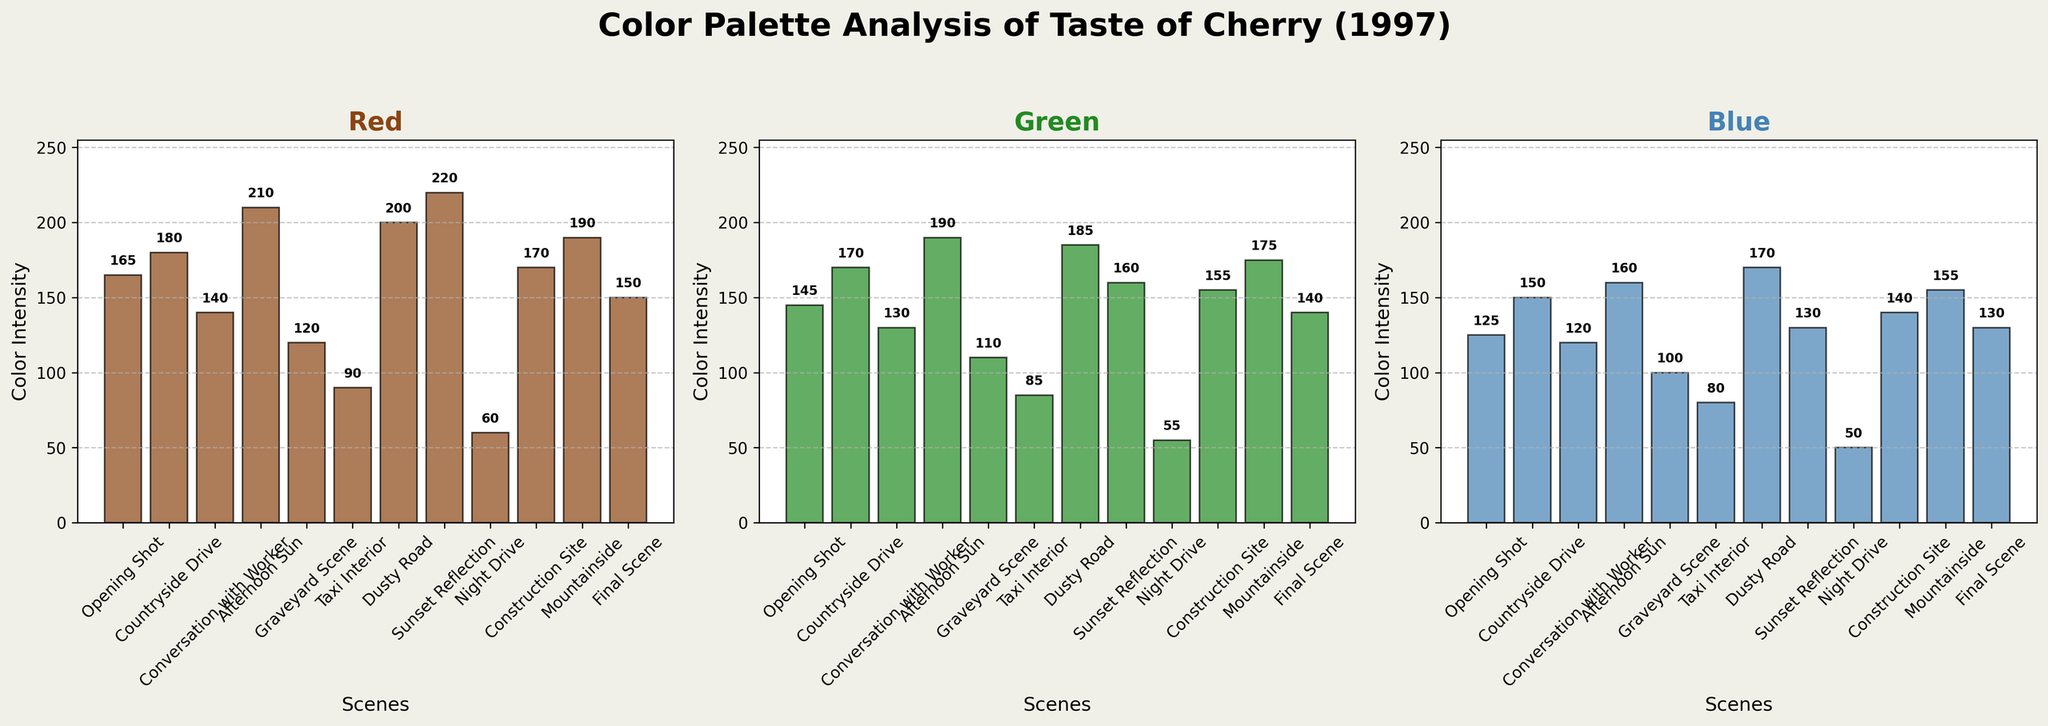What's the scene with the highest red intensity? Look at the plot representing the red intensity and identify which bar is the tallest.
Answer: Sunset Reflection Which scene has the lowest blue intensity? Observe the plot for blue intensity and find the shortest bar.
Answer: Night Drive What is the difference in green intensity between 'Afternoon Sun' and 'Night Drive'? Find the green intensity values for 'Afternoon Sun' (190) and 'Night Drive' (55), then subtract the latter from the former. 190 - 55 = 135
Answer: 135 What is the average blue intensity across all scenes? Sum all blue intensity values and divide by the number of scenes (12). (125+150+120+160+100+80+170+130+50+140+155+130)/12 ≈ 122.08
Answer: 122.08 Is the red intensity of 'Countryside Drive' higher than the red intensity of 'Final Scene'? Compare the red intensity values for 'Countryside Drive' (180) and 'Final Scene' (150). 180 > 150
Answer: Yes What is the total red intensity for 'Opening Shot', 'Graveyard Scene', and 'Taxi Interior'? Sum the red intensity values of 'Opening Shot' (165), 'Graveyard Scene' (120), and 'Taxi Interior' (90). 165 + 120 + 90 = 375
Answer: 375 Which color has the highest intensity in 'Mountainside'? Compare the intensity values of red (190), green (175), and blue (155) for 'Mountainside' and identify the highest.
Answer: Red Which scene has the highest combined intensity of all three colors? For each scene, sum the red, green, and blue intensities, and identify the scene with the highest total. 'Afternoon Sun' has the highest combined intensity of 210+190+160 = 560
Answer: Afternoon Sun Are the blue intensities of 'Conversation with Worker' and 'Final Scene' equal? Compare the blue intensity values for 'Conversation with Worker' (120) and 'Final Scene' (130).
Answer: No 